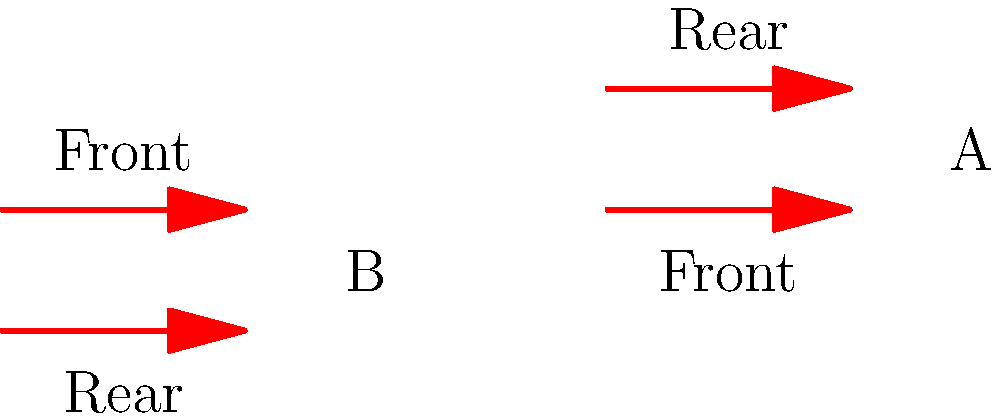As a young soldier, you've been asked to identify the tactical formation that provides better flank protection during a forward advance. Compare formations A and B shown in the diagram. Which formation offers superior flank security and why? To determine which formation offers better flank protection during a forward advance, let's analyze both formations:

1. Formation A:
   - Two parallel lines of troops
   - Three soldiers in each line
   - Front and rear lines aligned vertically

2. Formation B:
   - Two parallel lines of troops
   - Three soldiers in each line
   - Front and rear lines offset horizontally

Step-by-step analysis:
1. Flank vulnerability:
   - Formation A: The sides are completely exposed with no troops covering the flanks.
   - Formation B: The offset arrangement provides partial coverage of the flanks.

2. Field of view:
   - Formation A: Troops in each line have a limited view of the flanks.
   - Formation B: The offset allows both front and rear troops to observe the flanks more effectively.

3. Reaction time:
   - Formation A: In case of a flank attack, the formation would need to completely reorient.
   - Formation B: The offset positions allow for quicker response to flank threats.

4. Mutual support:
   - Formation A: Limited mutual support between front and rear lines for flank defense.
   - Formation B: Better mutual support due to the offset, allowing crossfire in case of flank attack.

5. Adaptability:
   - Formation A: Less flexible for rapid flank defense.
   - Formation B: Can more easily adapt to threats from the sides.

Considering these factors, Formation B offers superior flank security during a forward advance. The offset arrangement provides better observation, quicker reaction times, and improved mutual support for flank protection.
Answer: Formation B 